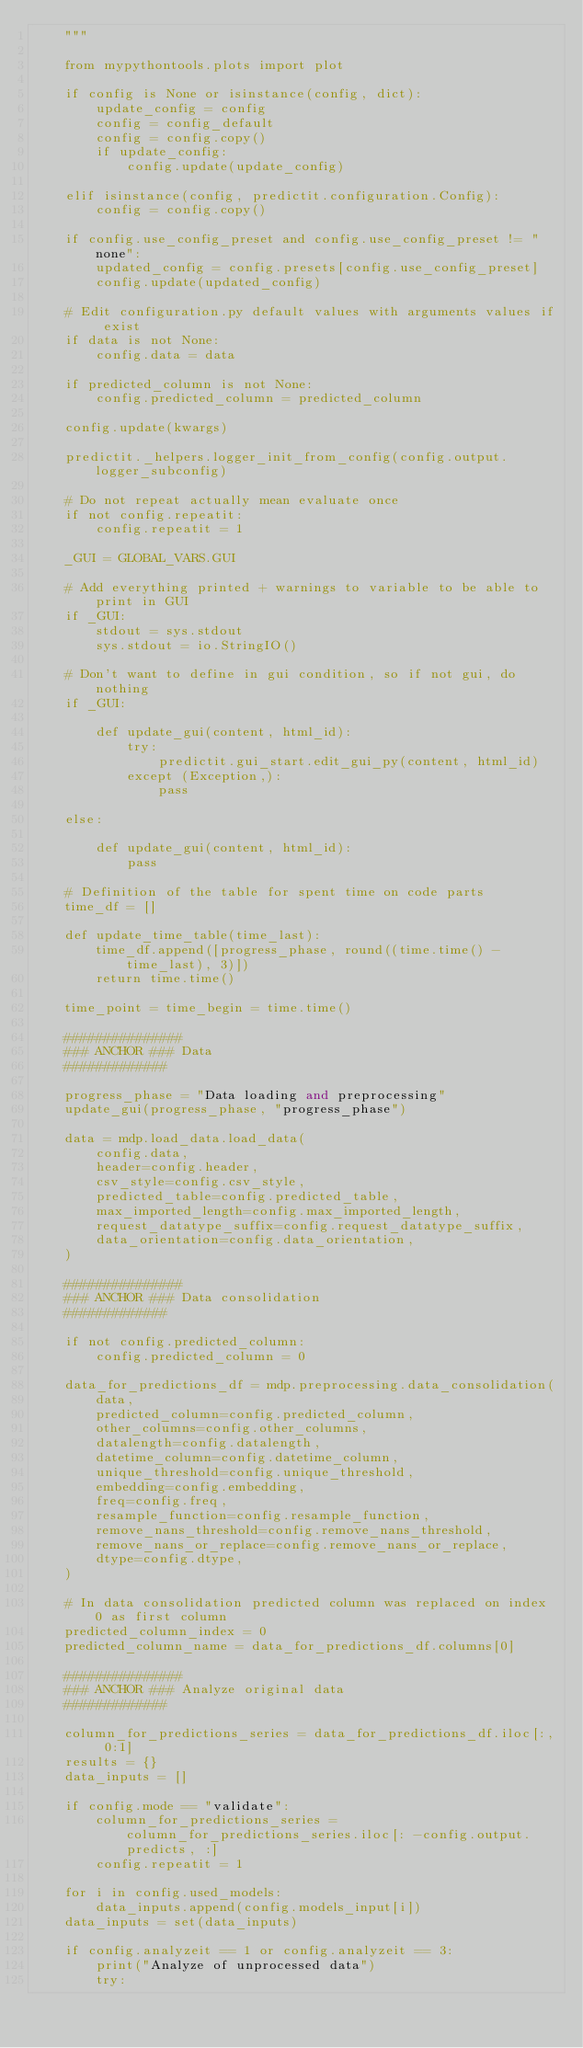Convert code to text. <code><loc_0><loc_0><loc_500><loc_500><_Python_>    """

    from mypythontools.plots import plot

    if config is None or isinstance(config, dict):
        update_config = config
        config = config_default
        config = config.copy()
        if update_config:
            config.update(update_config)

    elif isinstance(config, predictit.configuration.Config):
        config = config.copy()

    if config.use_config_preset and config.use_config_preset != "none":
        updated_config = config.presets[config.use_config_preset]
        config.update(updated_config)

    # Edit configuration.py default values with arguments values if exist
    if data is not None:
        config.data = data

    if predicted_column is not None:
        config.predicted_column = predicted_column

    config.update(kwargs)

    predictit._helpers.logger_init_from_config(config.output.logger_subconfig)

    # Do not repeat actually mean evaluate once
    if not config.repeatit:
        config.repeatit = 1

    _GUI = GLOBAL_VARS.GUI

    # Add everything printed + warnings to variable to be able to print in GUI
    if _GUI:
        stdout = sys.stdout
        sys.stdout = io.StringIO()

    # Don't want to define in gui condition, so if not gui, do nothing
    if _GUI:

        def update_gui(content, html_id):
            try:
                predictit.gui_start.edit_gui_py(content, html_id)
            except (Exception,):
                pass

    else:

        def update_gui(content, html_id):
            pass

    # Definition of the table for spent time on code parts
    time_df = []

    def update_time_table(time_last):
        time_df.append([progress_phase, round((time.time() - time_last), 3)])
        return time.time()

    time_point = time_begin = time.time()

    ###############
    ### ANCHOR ### Data
    #############

    progress_phase = "Data loading and preprocessing"
    update_gui(progress_phase, "progress_phase")

    data = mdp.load_data.load_data(
        config.data,
        header=config.header,
        csv_style=config.csv_style,
        predicted_table=config.predicted_table,
        max_imported_length=config.max_imported_length,
        request_datatype_suffix=config.request_datatype_suffix,
        data_orientation=config.data_orientation,
    )

    ###############
    ### ANCHOR ### Data consolidation
    #############

    if not config.predicted_column:
        config.predicted_column = 0

    data_for_predictions_df = mdp.preprocessing.data_consolidation(
        data,
        predicted_column=config.predicted_column,
        other_columns=config.other_columns,
        datalength=config.datalength,
        datetime_column=config.datetime_column,
        unique_threshold=config.unique_threshold,
        embedding=config.embedding,
        freq=config.freq,
        resample_function=config.resample_function,
        remove_nans_threshold=config.remove_nans_threshold,
        remove_nans_or_replace=config.remove_nans_or_replace,
        dtype=config.dtype,
    )

    # In data consolidation predicted column was replaced on index 0 as first column
    predicted_column_index = 0
    predicted_column_name = data_for_predictions_df.columns[0]

    ###############
    ### ANCHOR ### Analyze original data
    #############

    column_for_predictions_series = data_for_predictions_df.iloc[:, 0:1]
    results = {}
    data_inputs = []

    if config.mode == "validate":
        column_for_predictions_series = column_for_predictions_series.iloc[: -config.output.predicts, :]
        config.repeatit = 1

    for i in config.used_models:
        data_inputs.append(config.models_input[i])
    data_inputs = set(data_inputs)

    if config.analyzeit == 1 or config.analyzeit == 3:
        print("Analyze of unprocessed data")
        try:</code> 